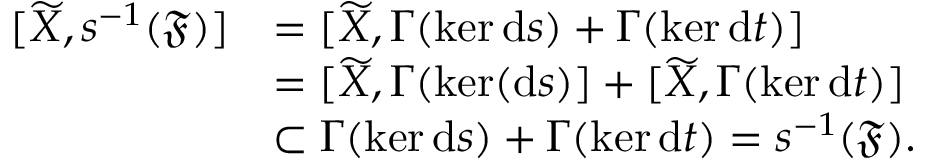<formula> <loc_0><loc_0><loc_500><loc_500>\begin{array} { r l } { [ \widetilde { X } , s ^ { - 1 } ( \mathfrak { F } ) ] } & { = [ \widetilde { X } , \Gamma ( \ker d s ) + \Gamma ( \ker d t ) ] } \\ & { = [ \widetilde { X } , \Gamma ( \ker ( d s ) ] + [ \widetilde { X } , \Gamma ( \ker d t ) ] } \\ & { \subset \Gamma ( \ker d s ) + \Gamma ( \ker d t ) = s ^ { - 1 } ( \mathfrak { F } ) . } \end{array}</formula> 